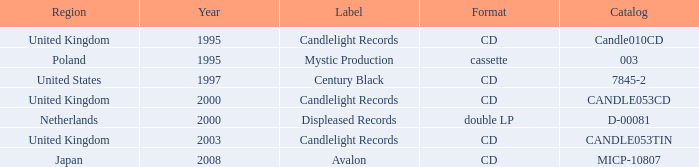Could you parse the entire table? {'header': ['Region', 'Year', 'Label', 'Format', 'Catalog'], 'rows': [['United Kingdom', '1995', 'Candlelight Records', 'CD', 'Candle010CD'], ['Poland', '1995', 'Mystic Production', 'cassette', '003'], ['United States', '1997', 'Century Black', 'CD', '7845-2'], ['United Kingdom', '2000', 'Candlelight Records', 'CD', 'CANDLE053CD'], ['Netherlands', '2000', 'Displeased Records', 'double LP', 'D-00081'], ['United Kingdom', '2003', 'Candlelight Records', 'CD', 'CANDLE053TIN'], ['Japan', '2008', 'Avalon', 'CD', 'MICP-10807']]} What is the arrangement of candlelight records? CD, CD, CD. 